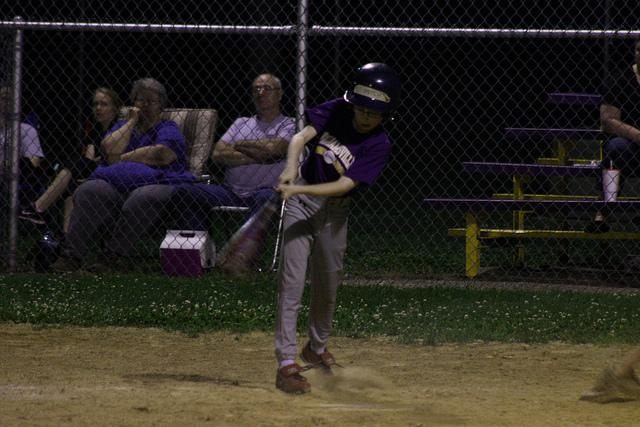If the boy is unsuccessful in doing what he is doing three times in a row what is it called?

Choices:
A) flag
B) strikeout
C) penalty
D) base hit strikeout 